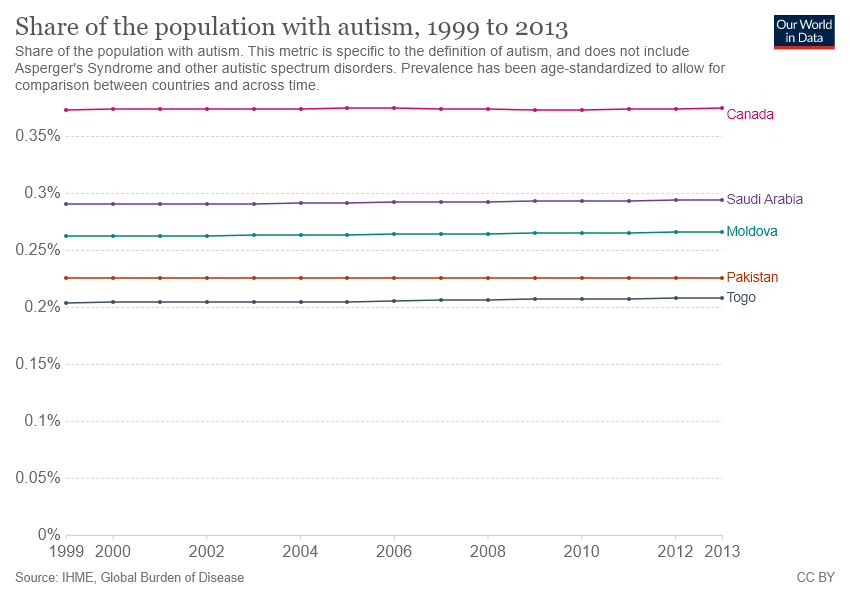Point out several critical features in this image. There are countries with a share of the population with autism lower than 0.25%, including Pakistan and Togo. It is Canada that has the highest proportion of its population diagnosed with autism. 